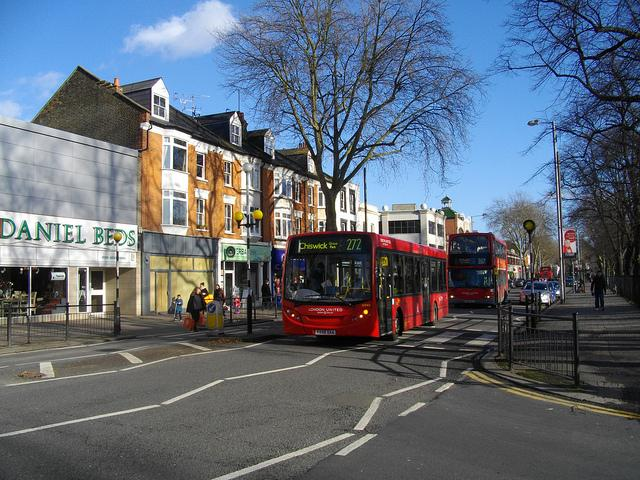What season is it in the image? winter 